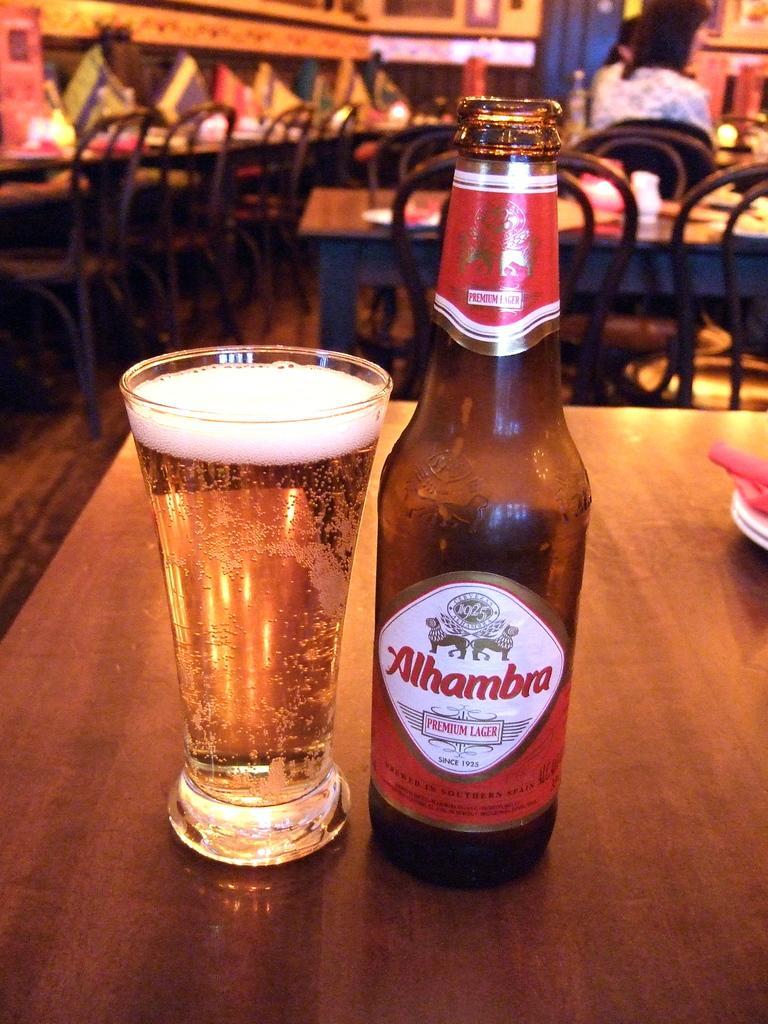Describe this image in one or two sentences. As we can see in the image there are tables and chairs. On table there is a bottle and glass. 